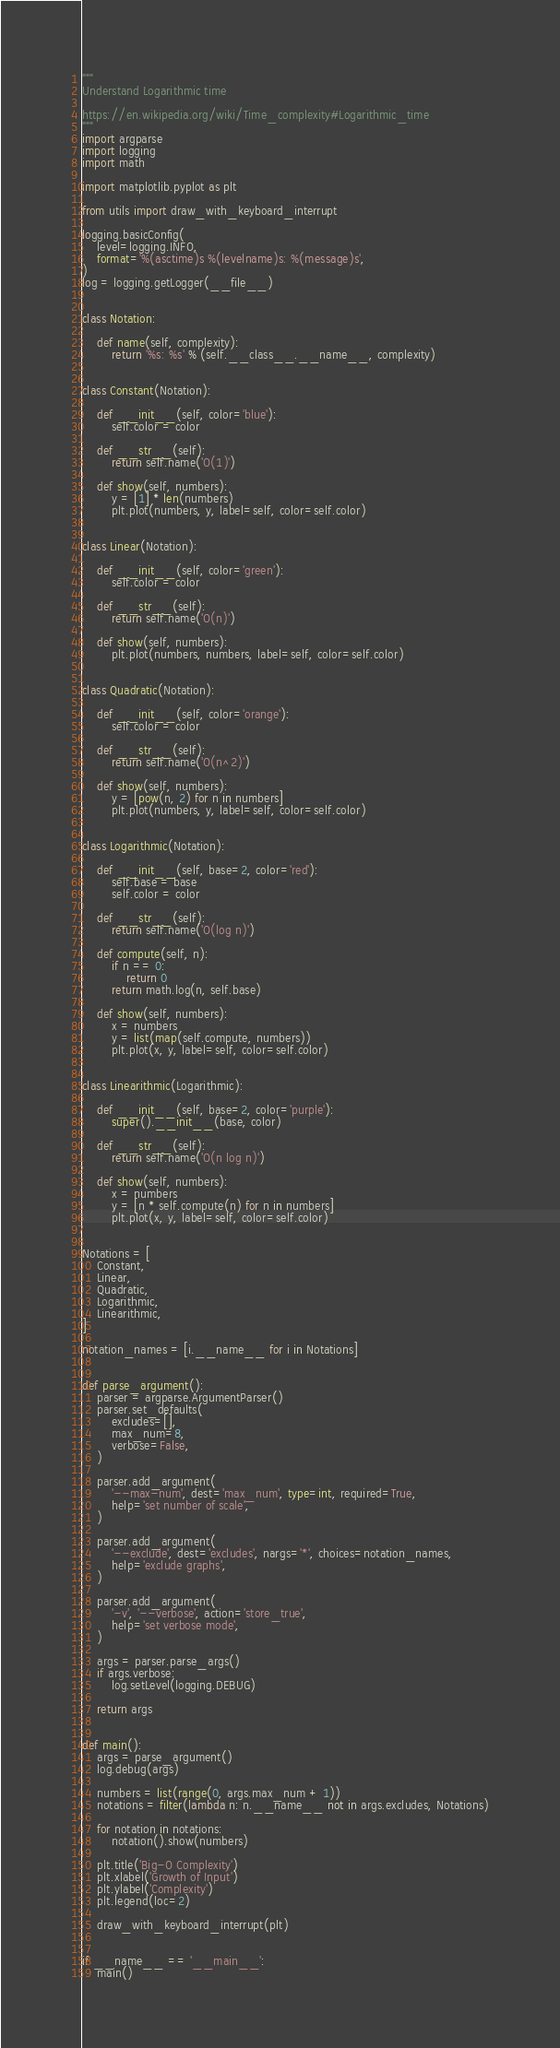Convert code to text. <code><loc_0><loc_0><loc_500><loc_500><_Python_>"""
Understand Logarithmic time

https://en.wikipedia.org/wiki/Time_complexity#Logarithmic_time
"""
import argparse
import logging
import math

import matplotlib.pyplot as plt

from utils import draw_with_keyboard_interrupt

logging.basicConfig(
    level=logging.INFO,
    format='%(asctime)s %(levelname)s: %(message)s',
)
log = logging.getLogger(__file__)


class Notation:

    def name(self, complexity):
        return '%s: %s' % (self.__class__.__name__, complexity)


class Constant(Notation):

    def __init__(self, color='blue'):
        self.color = color

    def __str__(self):
        return self.name('O(1)')

    def show(self, numbers):
        y = [1] * len(numbers)
        plt.plot(numbers, y, label=self, color=self.color)


class Linear(Notation):

    def __init__(self, color='green'):
        self.color = color

    def __str__(self):
        return self.name('O(n)')

    def show(self, numbers):
        plt.plot(numbers, numbers, label=self, color=self.color)


class Quadratic(Notation):

    def __init__(self, color='orange'):
        self.color = color

    def __str__(self):
        return self.name('O(n^2)')

    def show(self, numbers):
        y = [pow(n, 2) for n in numbers]
        plt.plot(numbers, y, label=self, color=self.color)


class Logarithmic(Notation):

    def __init__(self, base=2, color='red'):
        self.base = base
        self.color = color

    def __str__(self):
        return self.name('O(log n)')

    def compute(self, n):
        if n == 0:
            return 0
        return math.log(n, self.base)

    def show(self, numbers):
        x = numbers
        y = list(map(self.compute, numbers))
        plt.plot(x, y, label=self, color=self.color)


class Linearithmic(Logarithmic):

    def __init__(self, base=2, color='purple'):
        super().__init__(base, color)

    def __str__(self):
        return self.name('O(n log n)')

    def show(self, numbers):
        x = numbers
        y = [n * self.compute(n) for n in numbers]
        plt.plot(x, y, label=self, color=self.color)


Notations = [
    Constant,
    Linear,
    Quadratic,
    Logarithmic,
    Linearithmic,
]

notation_names = [i.__name__ for i in Notations]


def parse_argument():
    parser = argparse.ArgumentParser()
    parser.set_defaults(
        excludes=[],
        max_num=8,
        verbose=False,
    )

    parser.add_argument(
        '--max-num', dest='max_num', type=int, required=True,
        help='set number of scale',
    )

    parser.add_argument(
        '--exclude', dest='excludes', nargs='*', choices=notation_names,
        help='exclude graphs',
    )

    parser.add_argument(
        '-v', '--verbose', action='store_true',
        help='set verbose mode',
    )

    args = parser.parse_args()
    if args.verbose:
        log.setLevel(logging.DEBUG)

    return args


def main():
    args = parse_argument()
    log.debug(args)

    numbers = list(range(0, args.max_num + 1))
    notations = filter(lambda n: n.__name__ not in args.excludes, Notations)

    for notation in notations:
        notation().show(numbers)

    plt.title('Big-O Complexity')
    plt.xlabel('Growth of Input')
    plt.ylabel('Complexity')
    plt.legend(loc=2)

    draw_with_keyboard_interrupt(plt)


if __name__ == '__main__':
    main()
</code> 